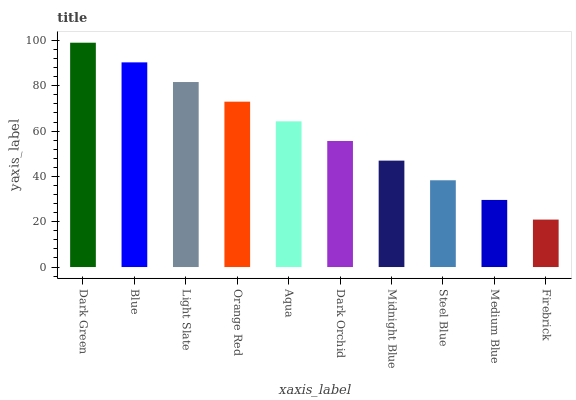Is Firebrick the minimum?
Answer yes or no. Yes. Is Dark Green the maximum?
Answer yes or no. Yes. Is Blue the minimum?
Answer yes or no. No. Is Blue the maximum?
Answer yes or no. No. Is Dark Green greater than Blue?
Answer yes or no. Yes. Is Blue less than Dark Green?
Answer yes or no. Yes. Is Blue greater than Dark Green?
Answer yes or no. No. Is Dark Green less than Blue?
Answer yes or no. No. Is Aqua the high median?
Answer yes or no. Yes. Is Dark Orchid the low median?
Answer yes or no. Yes. Is Steel Blue the high median?
Answer yes or no. No. Is Medium Blue the low median?
Answer yes or no. No. 